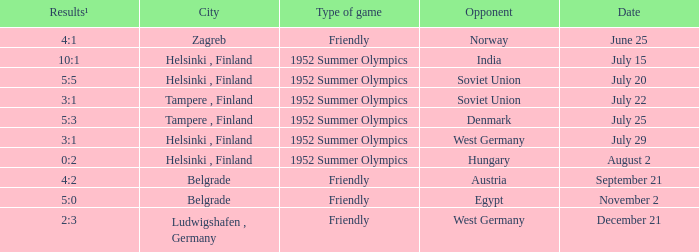What Type of game was played on Date of July 29? 1952 Summer Olympics. 